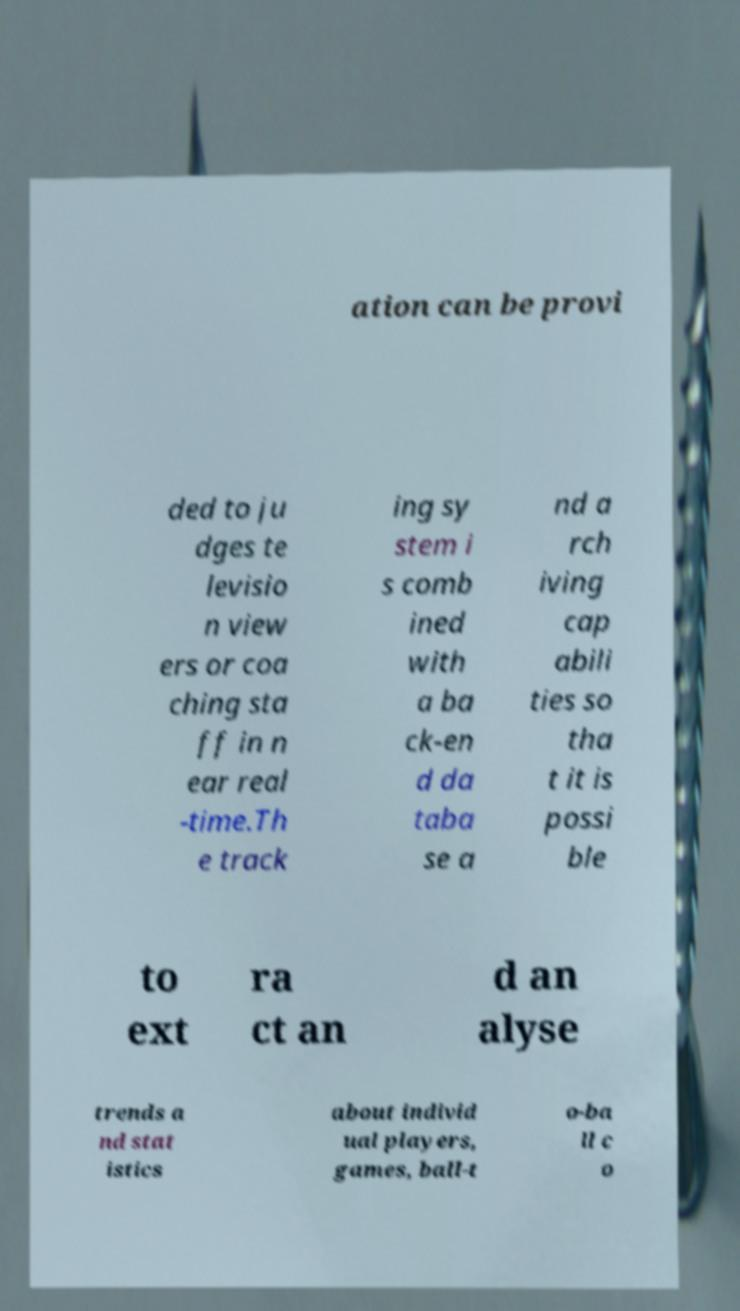I need the written content from this picture converted into text. Can you do that? ation can be provi ded to ju dges te levisio n view ers or coa ching sta ff in n ear real -time.Th e track ing sy stem i s comb ined with a ba ck-en d da taba se a nd a rch iving cap abili ties so tha t it is possi ble to ext ra ct an d an alyse trends a nd stat istics about individ ual players, games, ball-t o-ba ll c o 